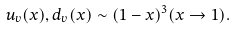Convert formula to latex. <formula><loc_0><loc_0><loc_500><loc_500>u _ { v } ( x ) , d _ { v } ( x ) \sim ( 1 - x ) ^ { 3 } ( x \to 1 ) .</formula> 